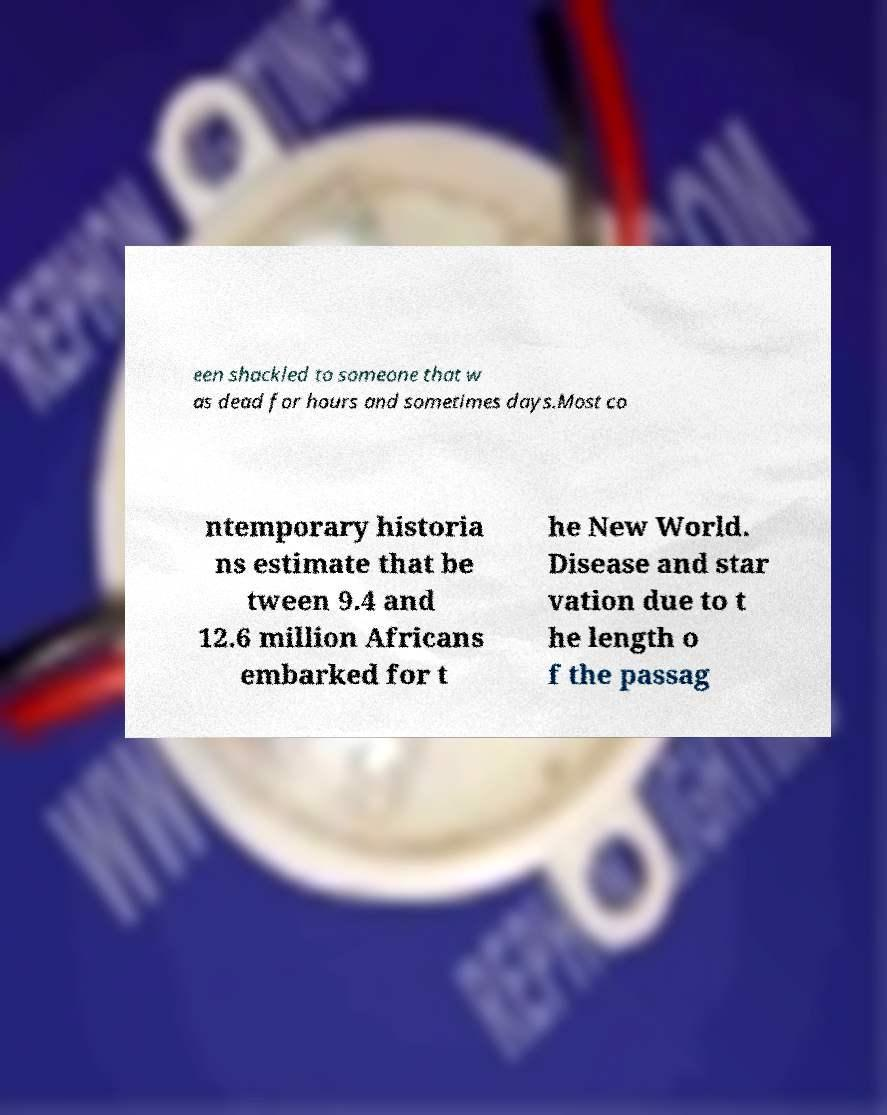For documentation purposes, I need the text within this image transcribed. Could you provide that? een shackled to someone that w as dead for hours and sometimes days.Most co ntemporary historia ns estimate that be tween 9.4 and 12.6 million Africans embarked for t he New World. Disease and star vation due to t he length o f the passag 